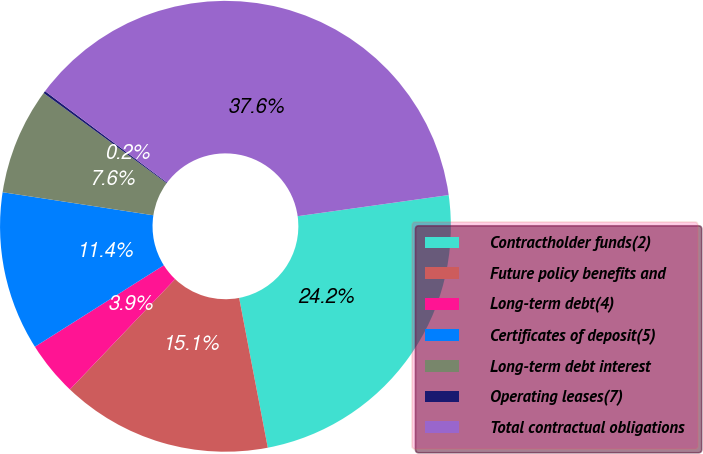<chart> <loc_0><loc_0><loc_500><loc_500><pie_chart><fcel>Contractholder funds(2)<fcel>Future policy benefits and<fcel>Long-term debt(4)<fcel>Certificates of deposit(5)<fcel>Long-term debt interest<fcel>Operating leases(7)<fcel>Total contractual obligations<nl><fcel>24.21%<fcel>15.13%<fcel>3.91%<fcel>11.39%<fcel>7.65%<fcel>0.17%<fcel>37.56%<nl></chart> 